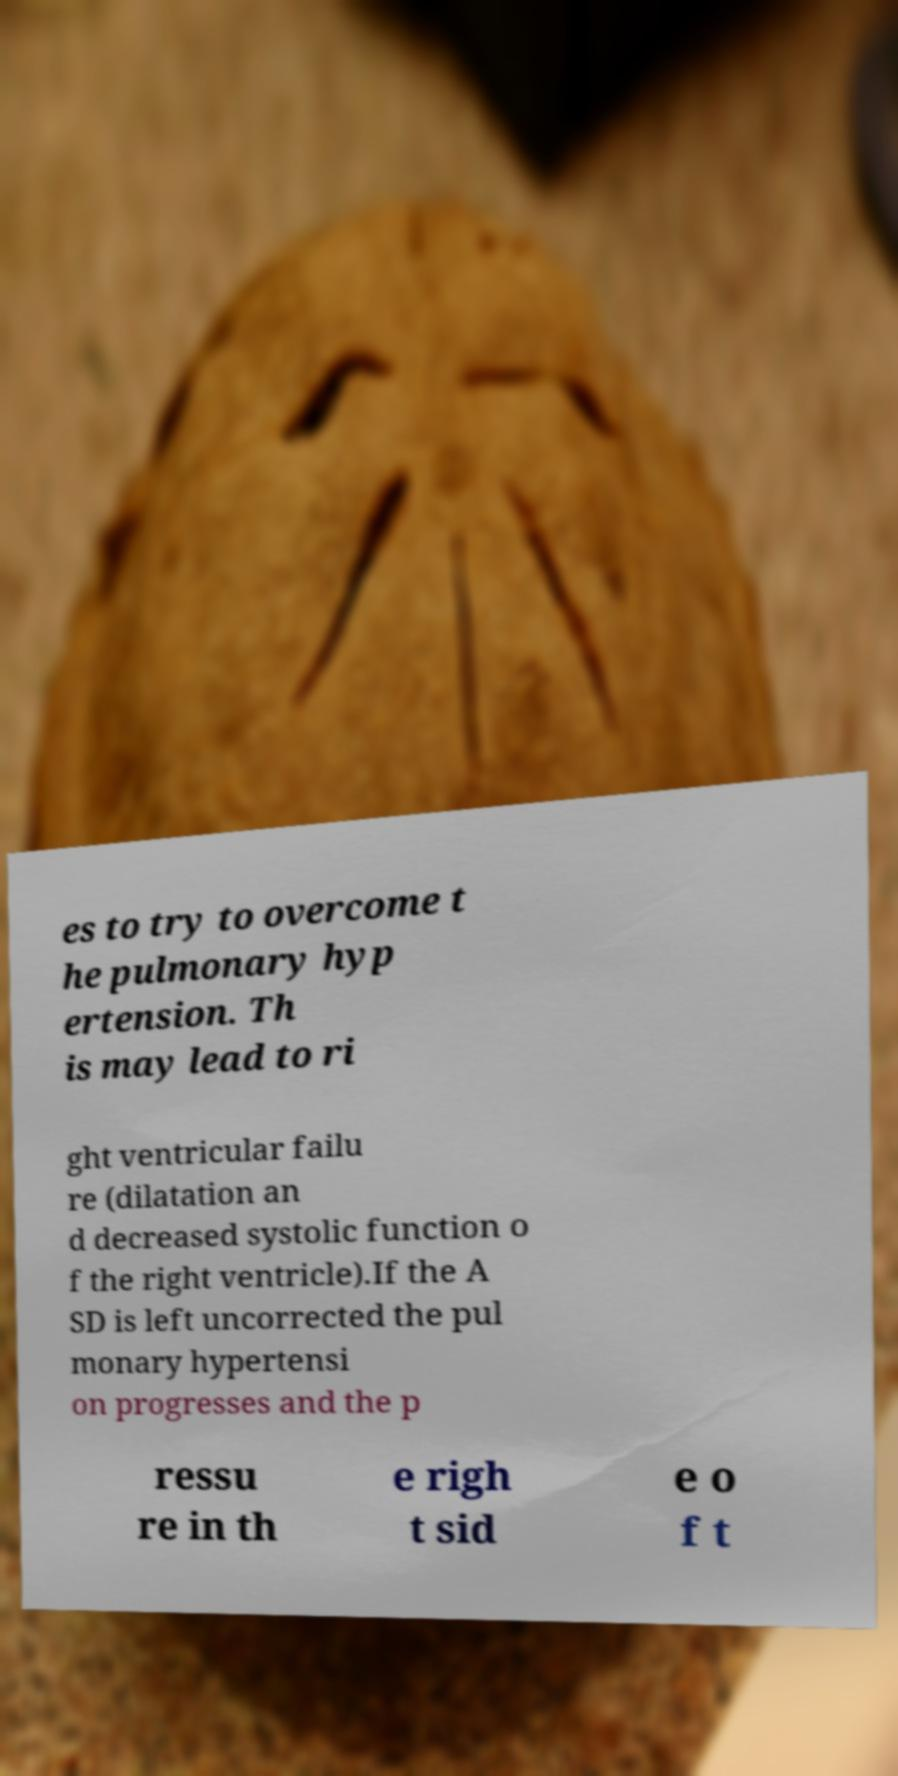Please identify and transcribe the text found in this image. es to try to overcome t he pulmonary hyp ertension. Th is may lead to ri ght ventricular failu re (dilatation an d decreased systolic function o f the right ventricle).If the A SD is left uncorrected the pul monary hypertensi on progresses and the p ressu re in th e righ t sid e o f t 